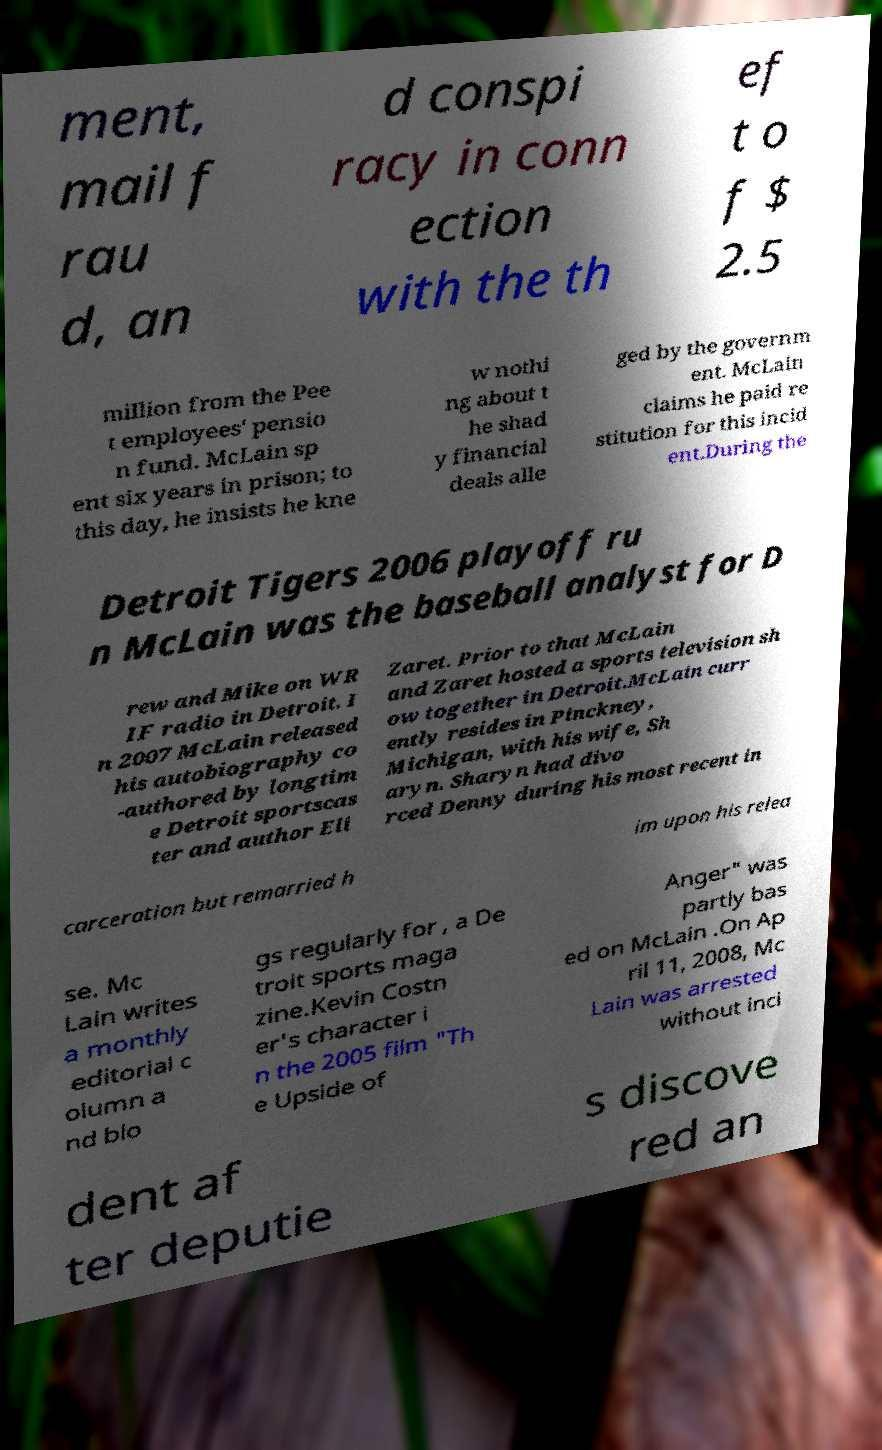Could you extract and type out the text from this image? ment, mail f rau d, an d conspi racy in conn ection with the th ef t o f $ 2.5 million from the Pee t employees' pensio n fund. McLain sp ent six years in prison; to this day, he insists he kne w nothi ng about t he shad y financial deals alle ged by the governm ent. McLain claims he paid re stitution for this incid ent.During the Detroit Tigers 2006 playoff ru n McLain was the baseball analyst for D rew and Mike on WR IF radio in Detroit. I n 2007 McLain released his autobiography co -authored by longtim e Detroit sportscas ter and author Eli Zaret. Prior to that McLain and Zaret hosted a sports television sh ow together in Detroit.McLain curr ently resides in Pinckney, Michigan, with his wife, Sh aryn. Sharyn had divo rced Denny during his most recent in carceration but remarried h im upon his relea se. Mc Lain writes a monthly editorial c olumn a nd blo gs regularly for , a De troit sports maga zine.Kevin Costn er's character i n the 2005 film "Th e Upside of Anger" was partly bas ed on McLain .On Ap ril 11, 2008, Mc Lain was arrested without inci dent af ter deputie s discove red an 